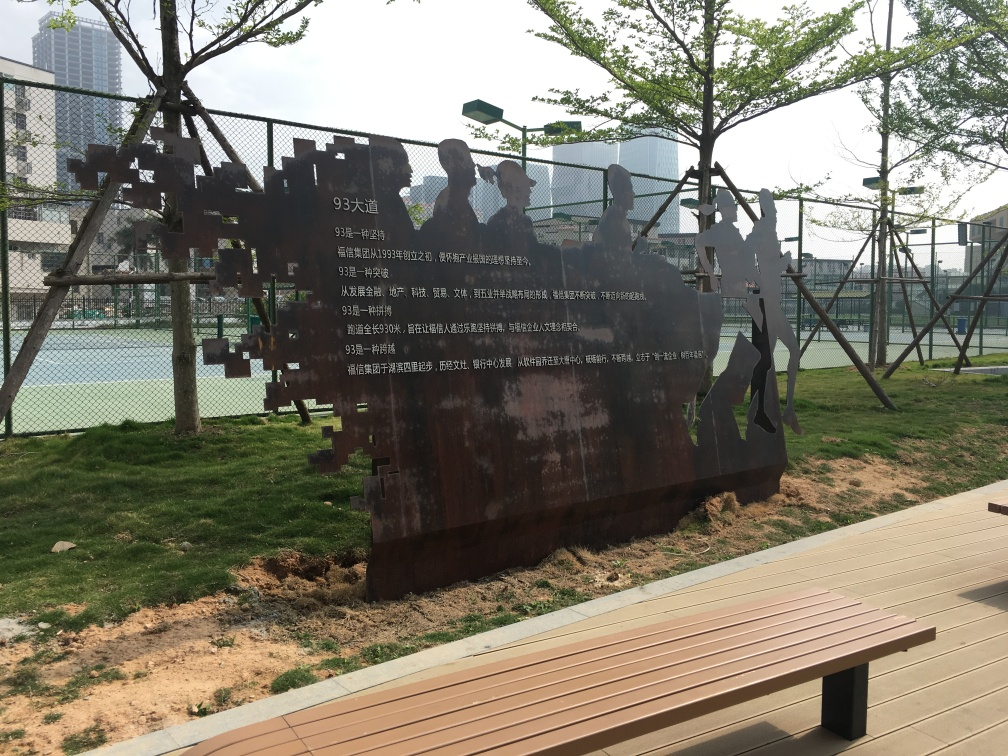How would you describe the texture details of the trees? The trees in the image exhibit a rich and varied texture. The leaves display a mosaic of greens that give off a fresh, vibrant look, while the tree trunks show a natural roughness typical of tree bark. Subtle differences in light and shadow further enhance the detailed textural qualities of the foliage and bark, which add to the overall richness of the scene. 